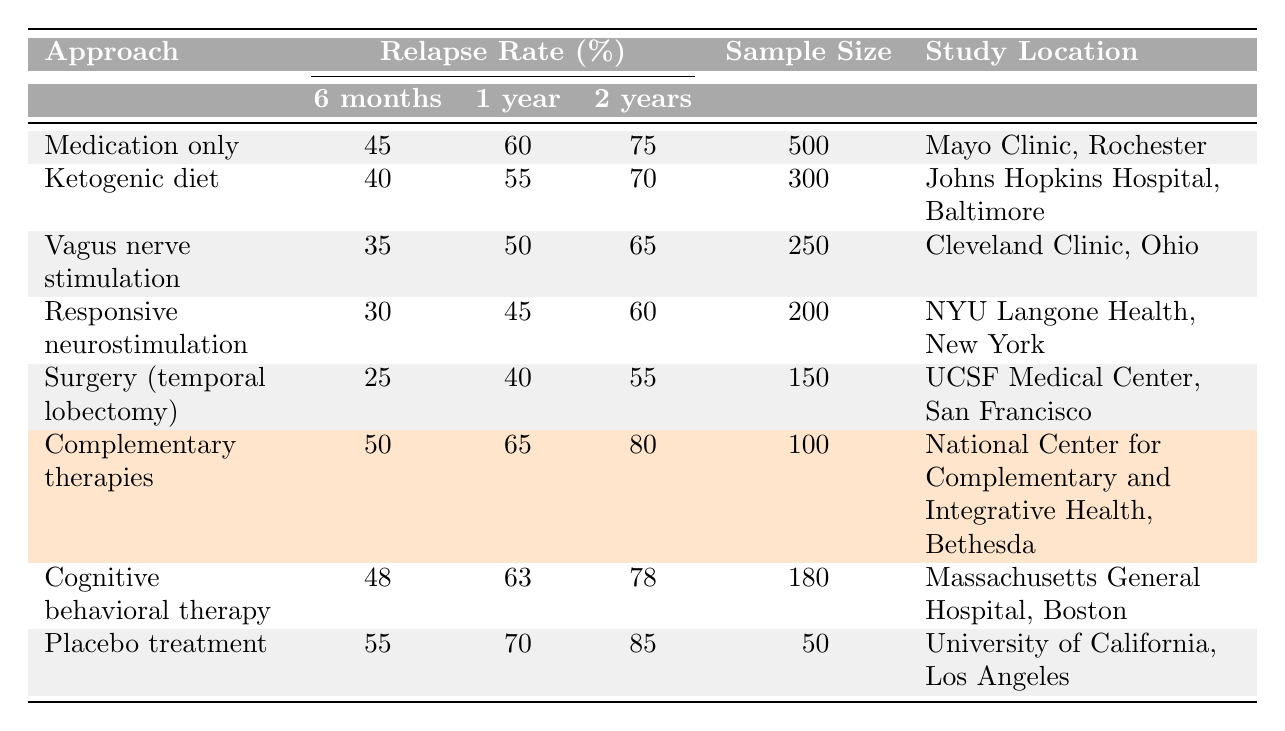What is the relapse rate for surgery (temporal lobectomy) after 1 year? According to the table, the relapse rate for surgery (temporal lobectomy) after 1 year is listed under the corresponding column, which shows 40%.
Answer: 40% Which epilepsy management approach has the highest relapse rate after 2 years? By examining the relapse rates after 2 years for each approach, the approach with the highest rate is "Placebo treatment" at 85%.
Answer: Placebo treatment What is the average relapse rate at 6 months for all approaches combined? To find the average, add the relapse rates for 6 months: 45 + 40 + 35 + 30 + 25 + 50 + 48 + 55 = 378. There are 8 approaches, so divide 378 by 8, which gives 47.25.
Answer: 47.25 What percentage of patients relapse within 6 months when using responsive neurostimulation? The table states that the relapse rate for responsive neurostimulation at 6 months is 30%.
Answer: 30% Is the relapse rate for the ketogenic diet higher than that for vagus nerve stimulation after 1 year? Comparing the two rates: the ketogenic diet has a relapse rate of 55% after 1 year, while vagus nerve stimulation has 50%. Therefore, the ketogenic diet has a higher relapse rate.
Answer: Yes What is the difference in relapse rates after 2 years between complementary therapies and cognitive behavioral therapy? The relapse rate for complementary therapies after 2 years is 80%, and for cognitive behavioral therapy, it is 78%. The difference is 80 - 78 = 2%.
Answer: 2% Which approach has the lowest relapse rate at 6 months and what is that rate? By reviewing the table, the lowest relapse rate at 6 months is from surgery (temporal lobectomy), which has a rate of 25%.
Answer: 25% If we consider only the approaches with a sample size over 200, what is the average relapse rate after 1 year for these approaches? The approaches with a sample size over 200 are: Medication only (60%), Ketogenic diet (55%), Vagus nerve stimulation (50%), and Responsive neurostimulation (45%). Adding these gives 60 + 55 + 50 + 45 = 210. There are 4 approaches, so the average is 210/4 = 52.5%.
Answer: 52.5% What study location corresponds to the approach with the second highest relapse rate after 1 year? The second highest relapse rate after 1 year is 70% for "Placebo treatment," which is conducted at the University of California, Los Angeles.
Answer: University of California, Los Angeles For what percentage of patients using the vagus nerve stimulation approach relapse within 6 months, and how does that compare to the rate for cognitive behavioral therapy? The relapse rate for vagus nerve stimulation after 6 months is 35%, while cognitive behavioral therapy has a rate of 48%. Thus, cognitive behavioral therapy has a higher relapse rate.
Answer: 35% and cognitive behavioral therapy is higher 